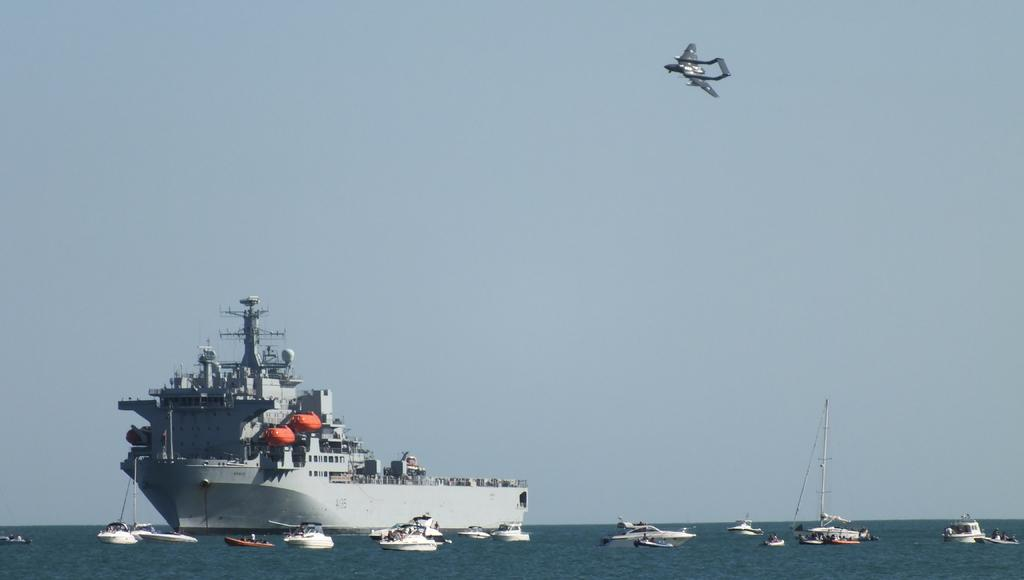What types of watercraft are visible in the image? There are ships and boats in the image. Where are the ships and boats located? The ships and boats are on the water. What else can be seen in the background of the image? There is an aircraft flying in the background of the image. What type of house is visible in the image? There is no house present in the image; it features ships, boats, and an aircraft. What pet can be seen accompanying the ships and boats in the image? There are no pets visible in the image; it only shows watercraft and an aircraft. 